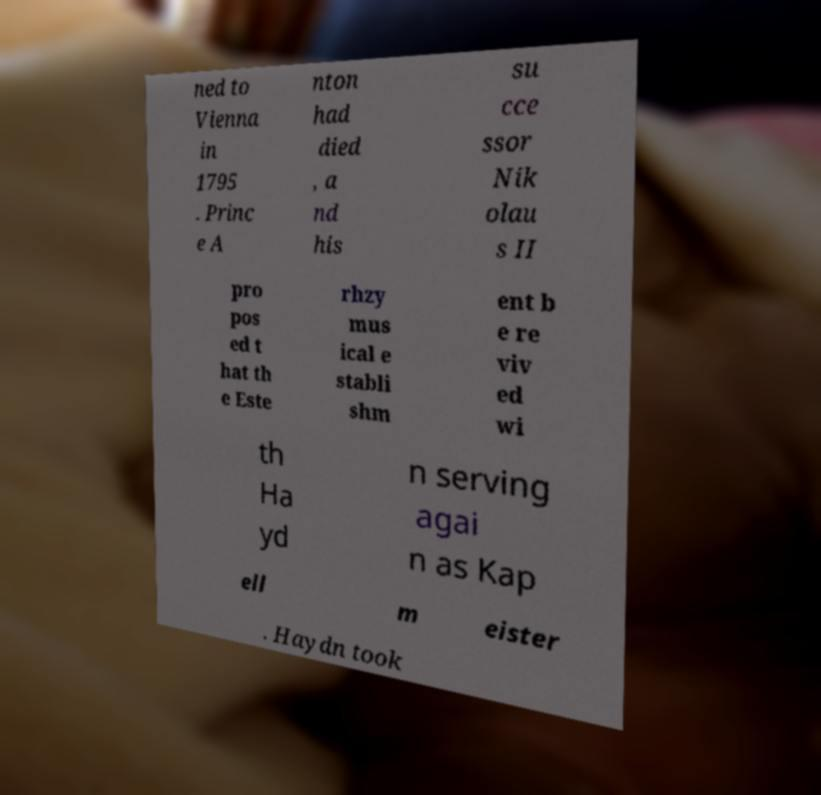What messages or text are displayed in this image? I need them in a readable, typed format. ned to Vienna in 1795 . Princ e A nton had died , a nd his su cce ssor Nik olau s II pro pos ed t hat th e Este rhzy mus ical e stabli shm ent b e re viv ed wi th Ha yd n serving agai n as Kap ell m eister . Haydn took 